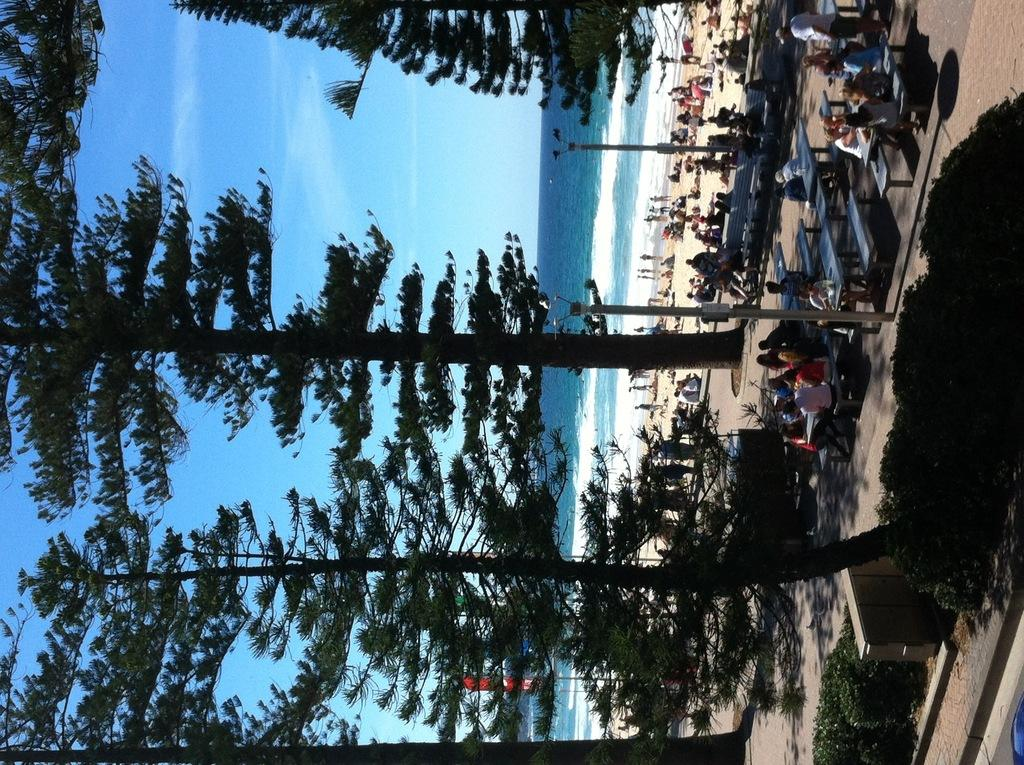What type of natural elements can be seen in the image? There are trees and plants in the image. What man-made structures are present in the image? There are poles, tables, and benches in the image. Are there any people in the image? Yes, there are people in the image. What additional feature can be seen in the image? There is a banner in the image. What is the condition of the sky in the image? The sky is cloudy in the image. What can be seen in the water in the image? The facts do not specify what can be seen in the water. What type of things does the partner of the representative in the image have? There is no mention of a partner or representative in the image, so this question cannot be answered. 